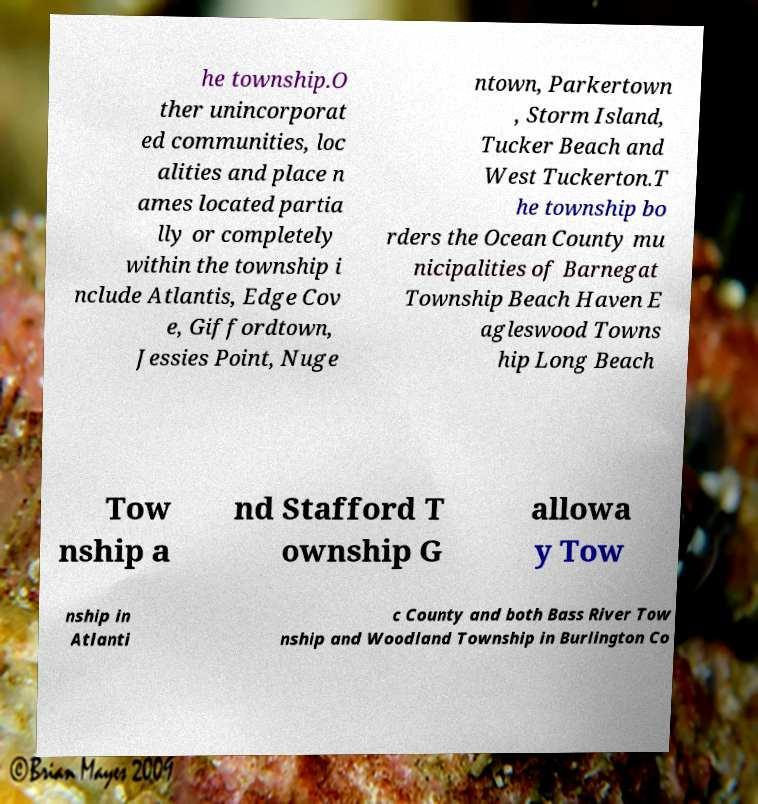I need the written content from this picture converted into text. Can you do that? he township.O ther unincorporat ed communities, loc alities and place n ames located partia lly or completely within the township i nclude Atlantis, Edge Cov e, Giffordtown, Jessies Point, Nuge ntown, Parkertown , Storm Island, Tucker Beach and West Tuckerton.T he township bo rders the Ocean County mu nicipalities of Barnegat Township Beach Haven E agleswood Towns hip Long Beach Tow nship a nd Stafford T ownship G allowa y Tow nship in Atlanti c County and both Bass River Tow nship and Woodland Township in Burlington Co 